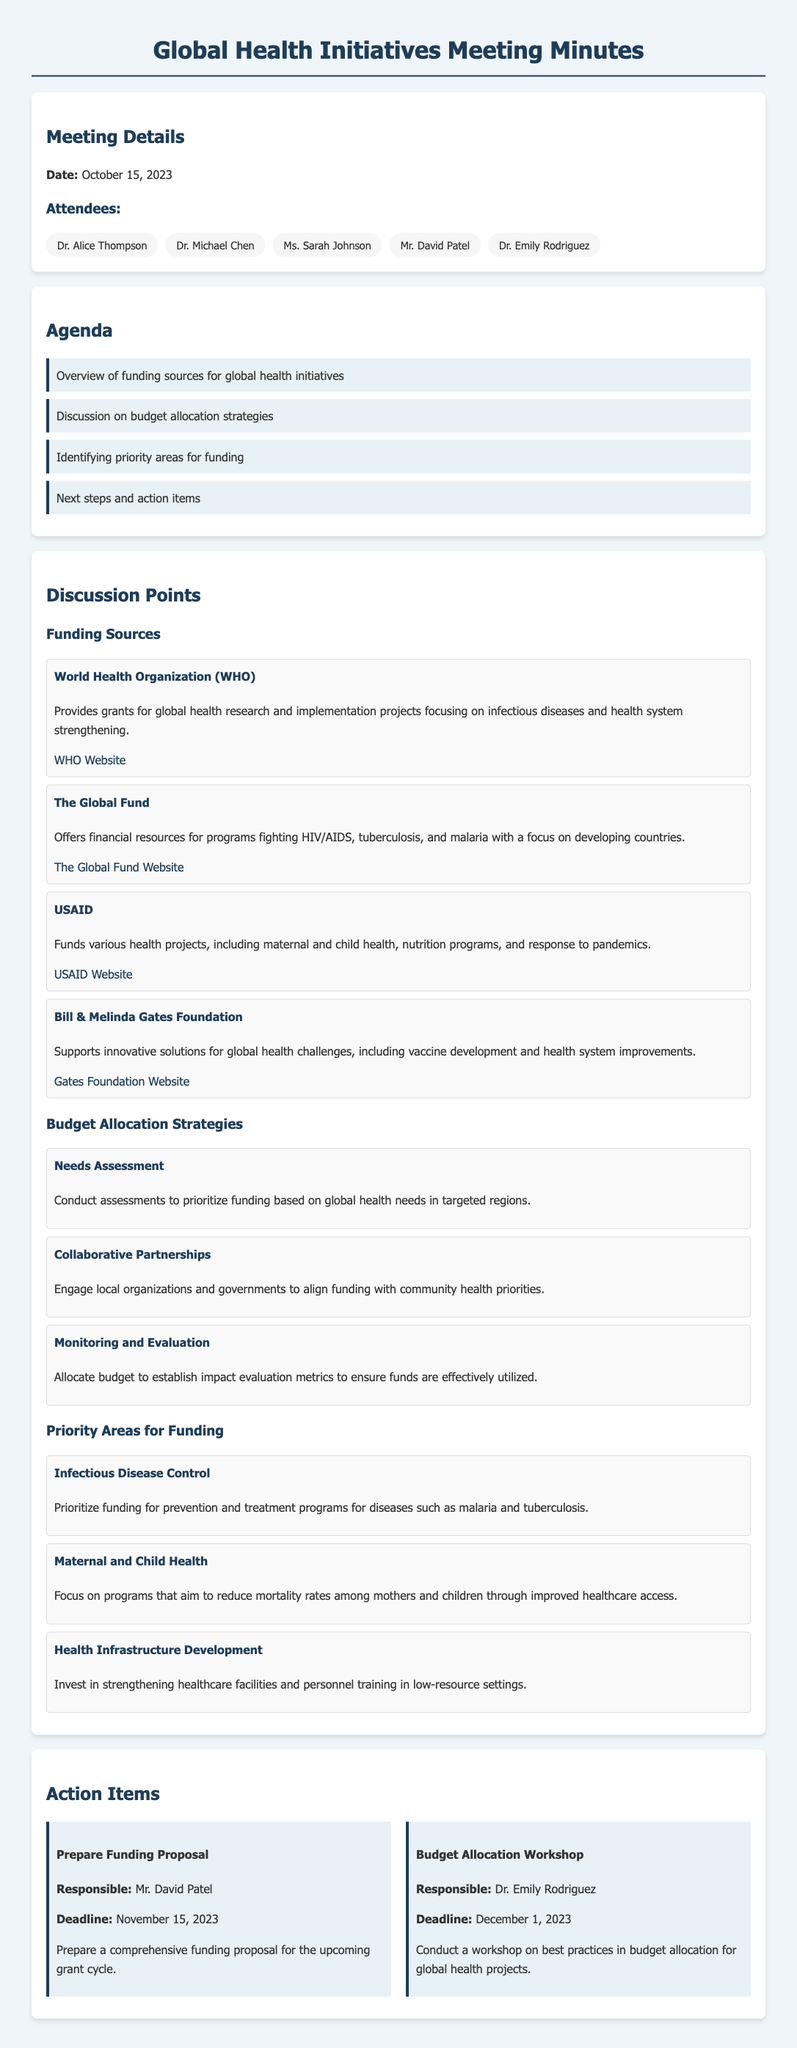What is the date of the meeting? The date of the meeting is explicitly mentioned in the 'Meeting Details' section.
Answer: October 15, 2023 Who is responsible for preparing the funding proposal? The action item for preparing the funding proposal specifies the person in charge.
Answer: Mr. David Patel What organization provides grants for global health research? The 'Funding Sources' section lists the organizations along with their details.
Answer: World Health Organization (WHO) What is one of the priority areas for funding mentioned? The priority areas for funding are listed in a specific section, highlighting key areas.
Answer: Infectious Disease Control What is the deadline for the budget allocation workshop? The deadline for the workshop on budget allocation is noted in the action item details.
Answer: December 1, 2023 What strategy involves engaging local organizations? The strategies for budget allocation include multiple approaches, one of which mentions local organizations.
Answer: Collaborative Partnerships How many attendees were present? The meeting details section lists all attendees, providing a total count.
Answer: Five What is the focus of USAID's funding? The information about USAID's focus is detailed under the funding sources section.
Answer: Maternal and child health 